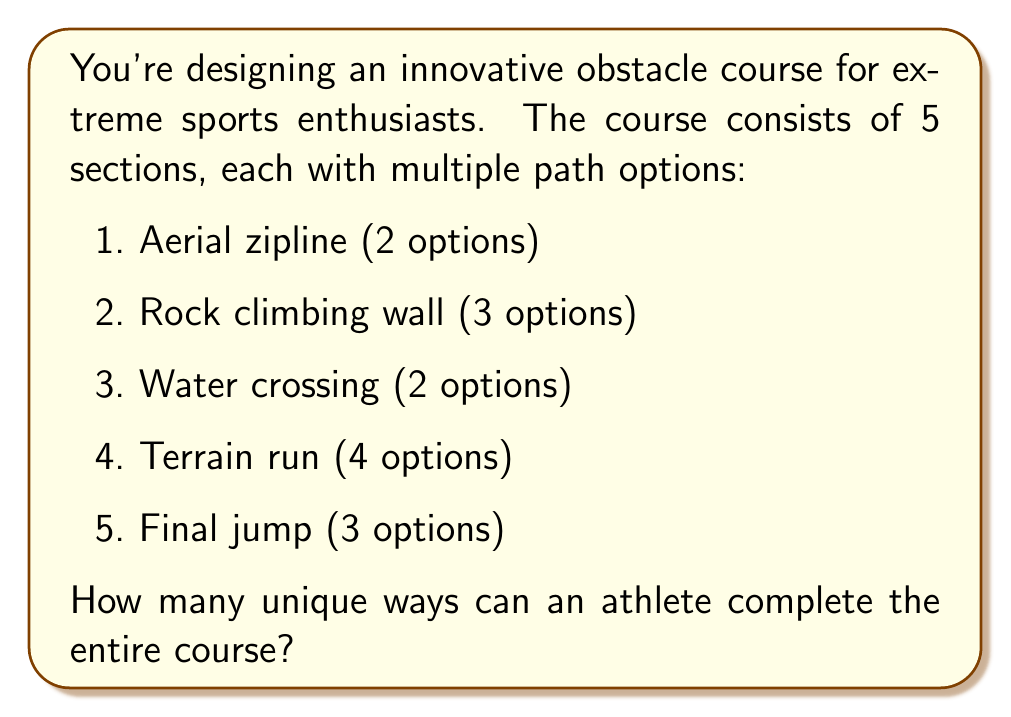Solve this math problem. Let's approach this step-by-step:

1) This problem is a perfect application of the multiplication principle in combinatorics. When we have a sequence of choices, and the number of choices for each step is independent of the choices made in other steps, we multiply the number of options for each step.

2) Let's break it down by section:
   - Aerial zipline: 2 options
   - Rock climbing wall: 3 options
   - Water crossing: 2 options
   - Terrain run: 4 options
   - Final jump: 3 options

3) To find the total number of unique ways to complete the course, we multiply these numbers:

   $$2 \times 3 \times 2 \times 4 \times 3$$

4) Let's calculate:
   $$2 \times 3 = 6$$
   $$6 \times 2 = 12$$
   $$12 \times 4 = 48$$
   $$48 \times 3 = 144$$

Therefore, there are 144 unique ways to complete the entire obstacle course.

This large number of possibilities showcases the versatility of your innovative course design, which could be a strong selling point for potential investors in your sporting equipment startup.
Answer: 144 